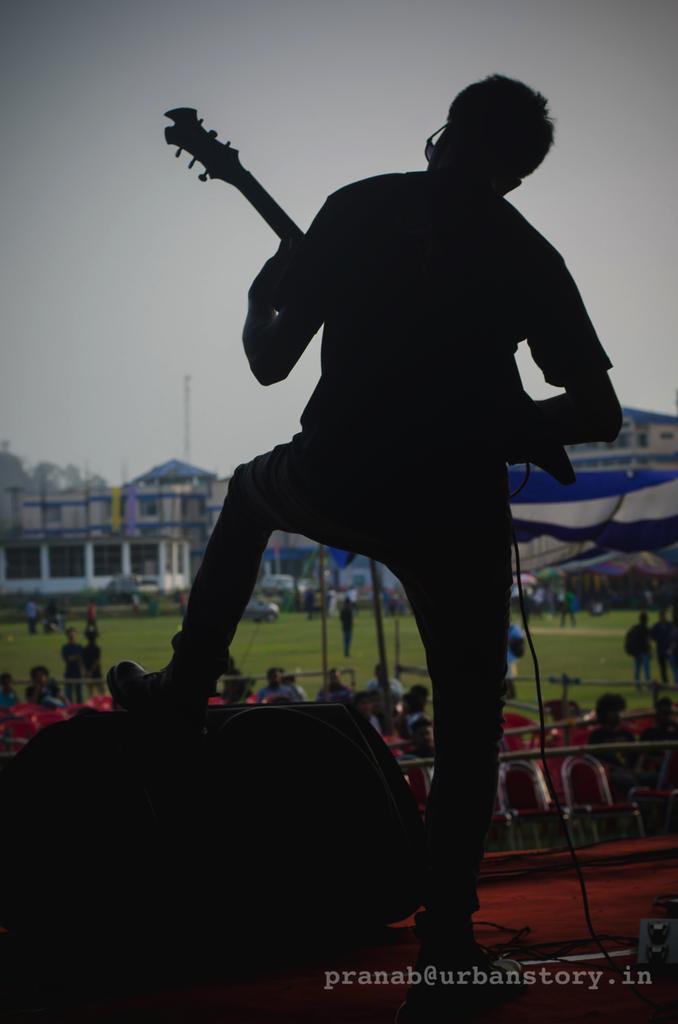Can you describe this image briefly? In this image the person is standing and holding the guitar. At the background we can see the building and a sky. 